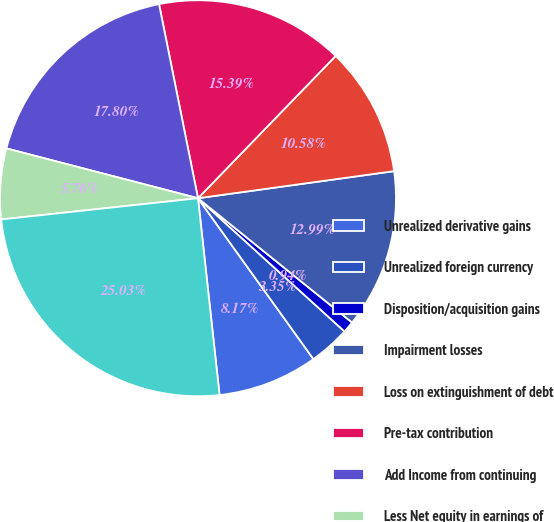<chart> <loc_0><loc_0><loc_500><loc_500><pie_chart><fcel>Unrealized derivative gains<fcel>Unrealized foreign currency<fcel>Disposition/acquisition gains<fcel>Impairment losses<fcel>Loss on extinguishment of debt<fcel>Pre-tax contribution<fcel>Add Income from continuing<fcel>Less Net equity in earnings of<fcel>Income from continuing<nl><fcel>8.17%<fcel>3.35%<fcel>0.94%<fcel>12.99%<fcel>10.58%<fcel>15.39%<fcel>17.8%<fcel>5.76%<fcel>25.03%<nl></chart> 